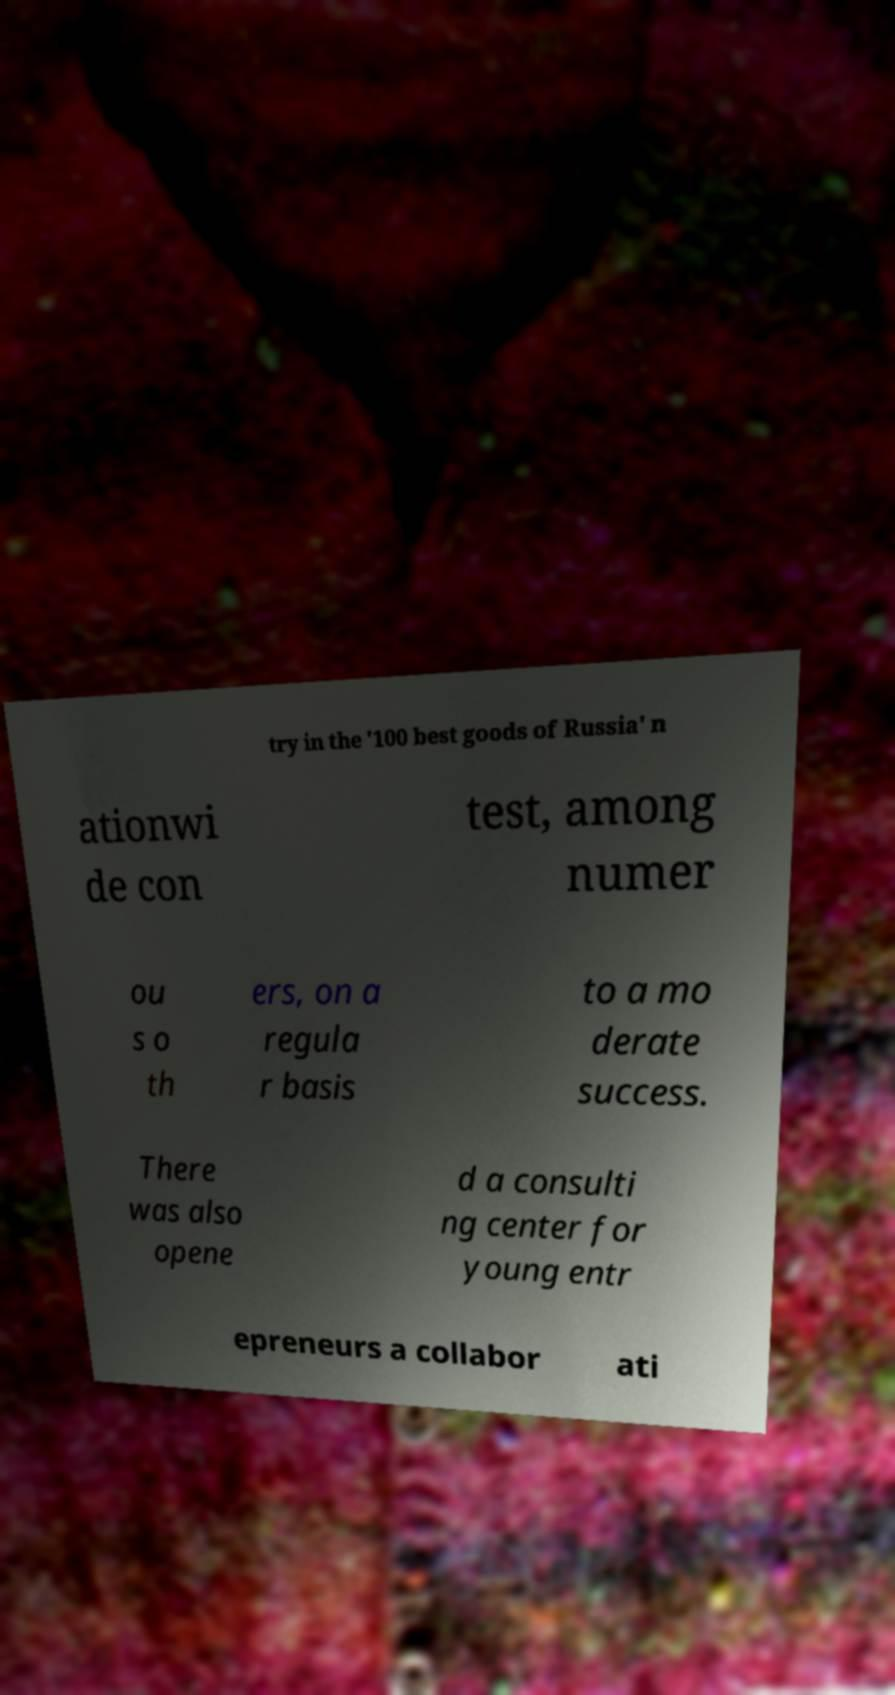I need the written content from this picture converted into text. Can you do that? try in the '100 best goods of Russia' n ationwi de con test, among numer ou s o th ers, on a regula r basis to a mo derate success. There was also opene d a consulti ng center for young entr epreneurs a collabor ati 